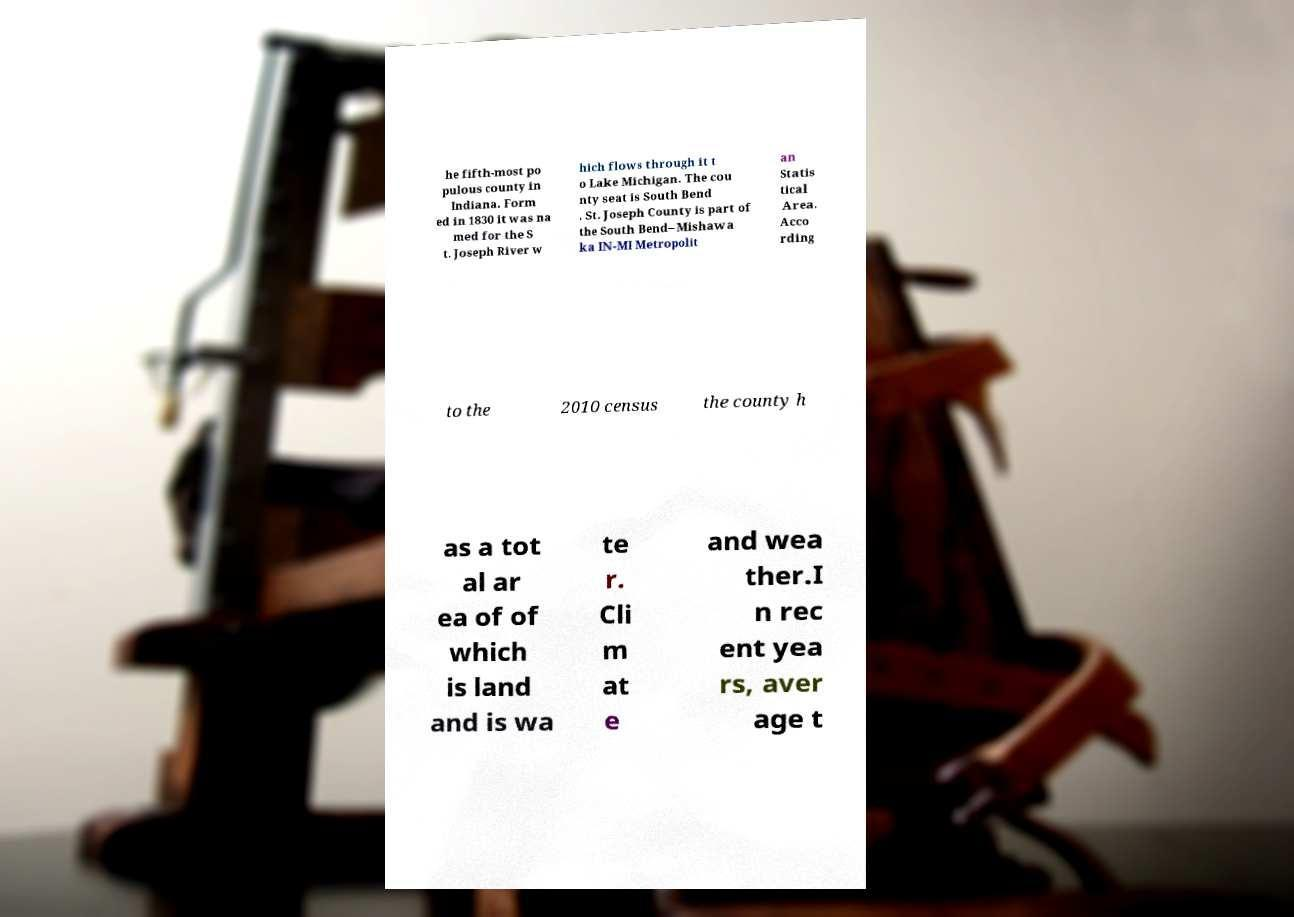Please identify and transcribe the text found in this image. he fifth-most po pulous county in Indiana. Form ed in 1830 it was na med for the S t. Joseph River w hich flows through it t o Lake Michigan. The cou nty seat is South Bend . St. Joseph County is part of the South Bend–Mishawa ka IN-MI Metropolit an Statis tical Area. Acco rding to the 2010 census the county h as a tot al ar ea of of which is land and is wa te r. Cli m at e and wea ther.I n rec ent yea rs, aver age t 